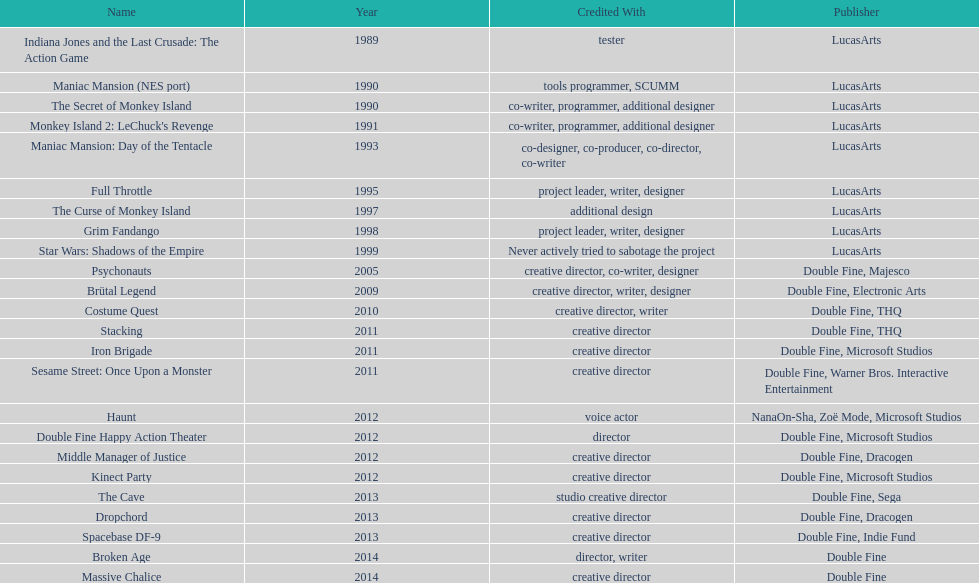How many games were credited with a creative director? 11. 